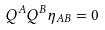Convert formula to latex. <formula><loc_0><loc_0><loc_500><loc_500>Q ^ { A } Q ^ { B } \eta _ { A B } = 0</formula> 